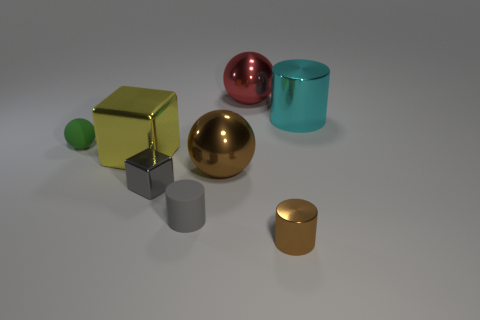Add 2 small cyan matte balls. How many objects exist? 10 Subtract all big spheres. How many spheres are left? 1 Add 7 tiny purple cylinders. How many tiny purple cylinders exist? 7 Subtract all gray cubes. How many cubes are left? 1 Subtract 1 brown cylinders. How many objects are left? 7 Subtract all balls. How many objects are left? 5 Subtract 3 spheres. How many spheres are left? 0 Subtract all blue balls. Subtract all purple blocks. How many balls are left? 3 Subtract all red cubes. How many gray spheres are left? 0 Subtract all small green balls. Subtract all tiny shiny objects. How many objects are left? 5 